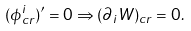<formula> <loc_0><loc_0><loc_500><loc_500>( \phi _ { c r } ^ { i } ) ^ { \prime } = 0 \Rightarrow ( \partial _ { i } W ) _ { c r } = 0 .</formula> 